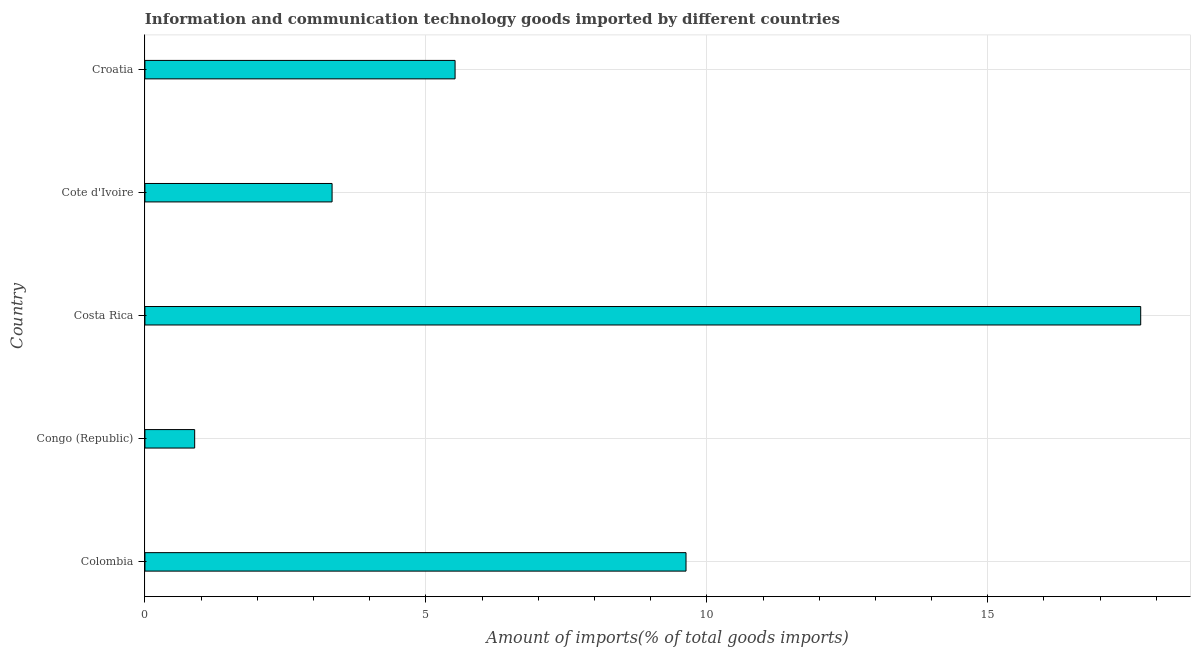Does the graph contain any zero values?
Give a very brief answer. No. What is the title of the graph?
Ensure brevity in your answer.  Information and communication technology goods imported by different countries. What is the label or title of the X-axis?
Give a very brief answer. Amount of imports(% of total goods imports). What is the label or title of the Y-axis?
Give a very brief answer. Country. What is the amount of ict goods imports in Croatia?
Give a very brief answer. 5.52. Across all countries, what is the maximum amount of ict goods imports?
Provide a succinct answer. 17.72. Across all countries, what is the minimum amount of ict goods imports?
Provide a succinct answer. 0.89. In which country was the amount of ict goods imports minimum?
Your response must be concise. Congo (Republic). What is the sum of the amount of ict goods imports?
Make the answer very short. 37.09. What is the difference between the amount of ict goods imports in Costa Rica and Cote d'Ivoire?
Offer a very short reply. 14.39. What is the average amount of ict goods imports per country?
Ensure brevity in your answer.  7.42. What is the median amount of ict goods imports?
Provide a short and direct response. 5.52. What is the ratio of the amount of ict goods imports in Colombia to that in Croatia?
Offer a very short reply. 1.75. Is the amount of ict goods imports in Congo (Republic) less than that in Cote d'Ivoire?
Ensure brevity in your answer.  Yes. What is the difference between the highest and the second highest amount of ict goods imports?
Provide a succinct answer. 8.09. Is the sum of the amount of ict goods imports in Colombia and Costa Rica greater than the maximum amount of ict goods imports across all countries?
Provide a succinct answer. Yes. What is the difference between the highest and the lowest amount of ict goods imports?
Ensure brevity in your answer.  16.84. In how many countries, is the amount of ict goods imports greater than the average amount of ict goods imports taken over all countries?
Provide a short and direct response. 2. How many bars are there?
Ensure brevity in your answer.  5. How many countries are there in the graph?
Make the answer very short. 5. What is the difference between two consecutive major ticks on the X-axis?
Provide a short and direct response. 5. Are the values on the major ticks of X-axis written in scientific E-notation?
Keep it short and to the point. No. What is the Amount of imports(% of total goods imports) in Colombia?
Your answer should be very brief. 9.63. What is the Amount of imports(% of total goods imports) in Congo (Republic)?
Ensure brevity in your answer.  0.89. What is the Amount of imports(% of total goods imports) of Costa Rica?
Offer a terse response. 17.72. What is the Amount of imports(% of total goods imports) of Cote d'Ivoire?
Offer a very short reply. 3.33. What is the Amount of imports(% of total goods imports) of Croatia?
Offer a terse response. 5.52. What is the difference between the Amount of imports(% of total goods imports) in Colombia and Congo (Republic)?
Provide a succinct answer. 8.74. What is the difference between the Amount of imports(% of total goods imports) in Colombia and Costa Rica?
Offer a terse response. -8.09. What is the difference between the Amount of imports(% of total goods imports) in Colombia and Cote d'Ivoire?
Your answer should be very brief. 6.3. What is the difference between the Amount of imports(% of total goods imports) in Colombia and Croatia?
Provide a succinct answer. 4.11. What is the difference between the Amount of imports(% of total goods imports) in Congo (Republic) and Costa Rica?
Keep it short and to the point. -16.84. What is the difference between the Amount of imports(% of total goods imports) in Congo (Republic) and Cote d'Ivoire?
Ensure brevity in your answer.  -2.45. What is the difference between the Amount of imports(% of total goods imports) in Congo (Republic) and Croatia?
Offer a terse response. -4.63. What is the difference between the Amount of imports(% of total goods imports) in Costa Rica and Cote d'Ivoire?
Make the answer very short. 14.39. What is the difference between the Amount of imports(% of total goods imports) in Costa Rica and Croatia?
Offer a terse response. 12.2. What is the difference between the Amount of imports(% of total goods imports) in Cote d'Ivoire and Croatia?
Your response must be concise. -2.19. What is the ratio of the Amount of imports(% of total goods imports) in Colombia to that in Congo (Republic)?
Provide a succinct answer. 10.88. What is the ratio of the Amount of imports(% of total goods imports) in Colombia to that in Costa Rica?
Your answer should be very brief. 0.54. What is the ratio of the Amount of imports(% of total goods imports) in Colombia to that in Cote d'Ivoire?
Offer a very short reply. 2.89. What is the ratio of the Amount of imports(% of total goods imports) in Colombia to that in Croatia?
Ensure brevity in your answer.  1.75. What is the ratio of the Amount of imports(% of total goods imports) in Congo (Republic) to that in Costa Rica?
Provide a short and direct response. 0.05. What is the ratio of the Amount of imports(% of total goods imports) in Congo (Republic) to that in Cote d'Ivoire?
Ensure brevity in your answer.  0.27. What is the ratio of the Amount of imports(% of total goods imports) in Congo (Republic) to that in Croatia?
Make the answer very short. 0.16. What is the ratio of the Amount of imports(% of total goods imports) in Costa Rica to that in Cote d'Ivoire?
Keep it short and to the point. 5.32. What is the ratio of the Amount of imports(% of total goods imports) in Costa Rica to that in Croatia?
Make the answer very short. 3.21. What is the ratio of the Amount of imports(% of total goods imports) in Cote d'Ivoire to that in Croatia?
Provide a succinct answer. 0.6. 